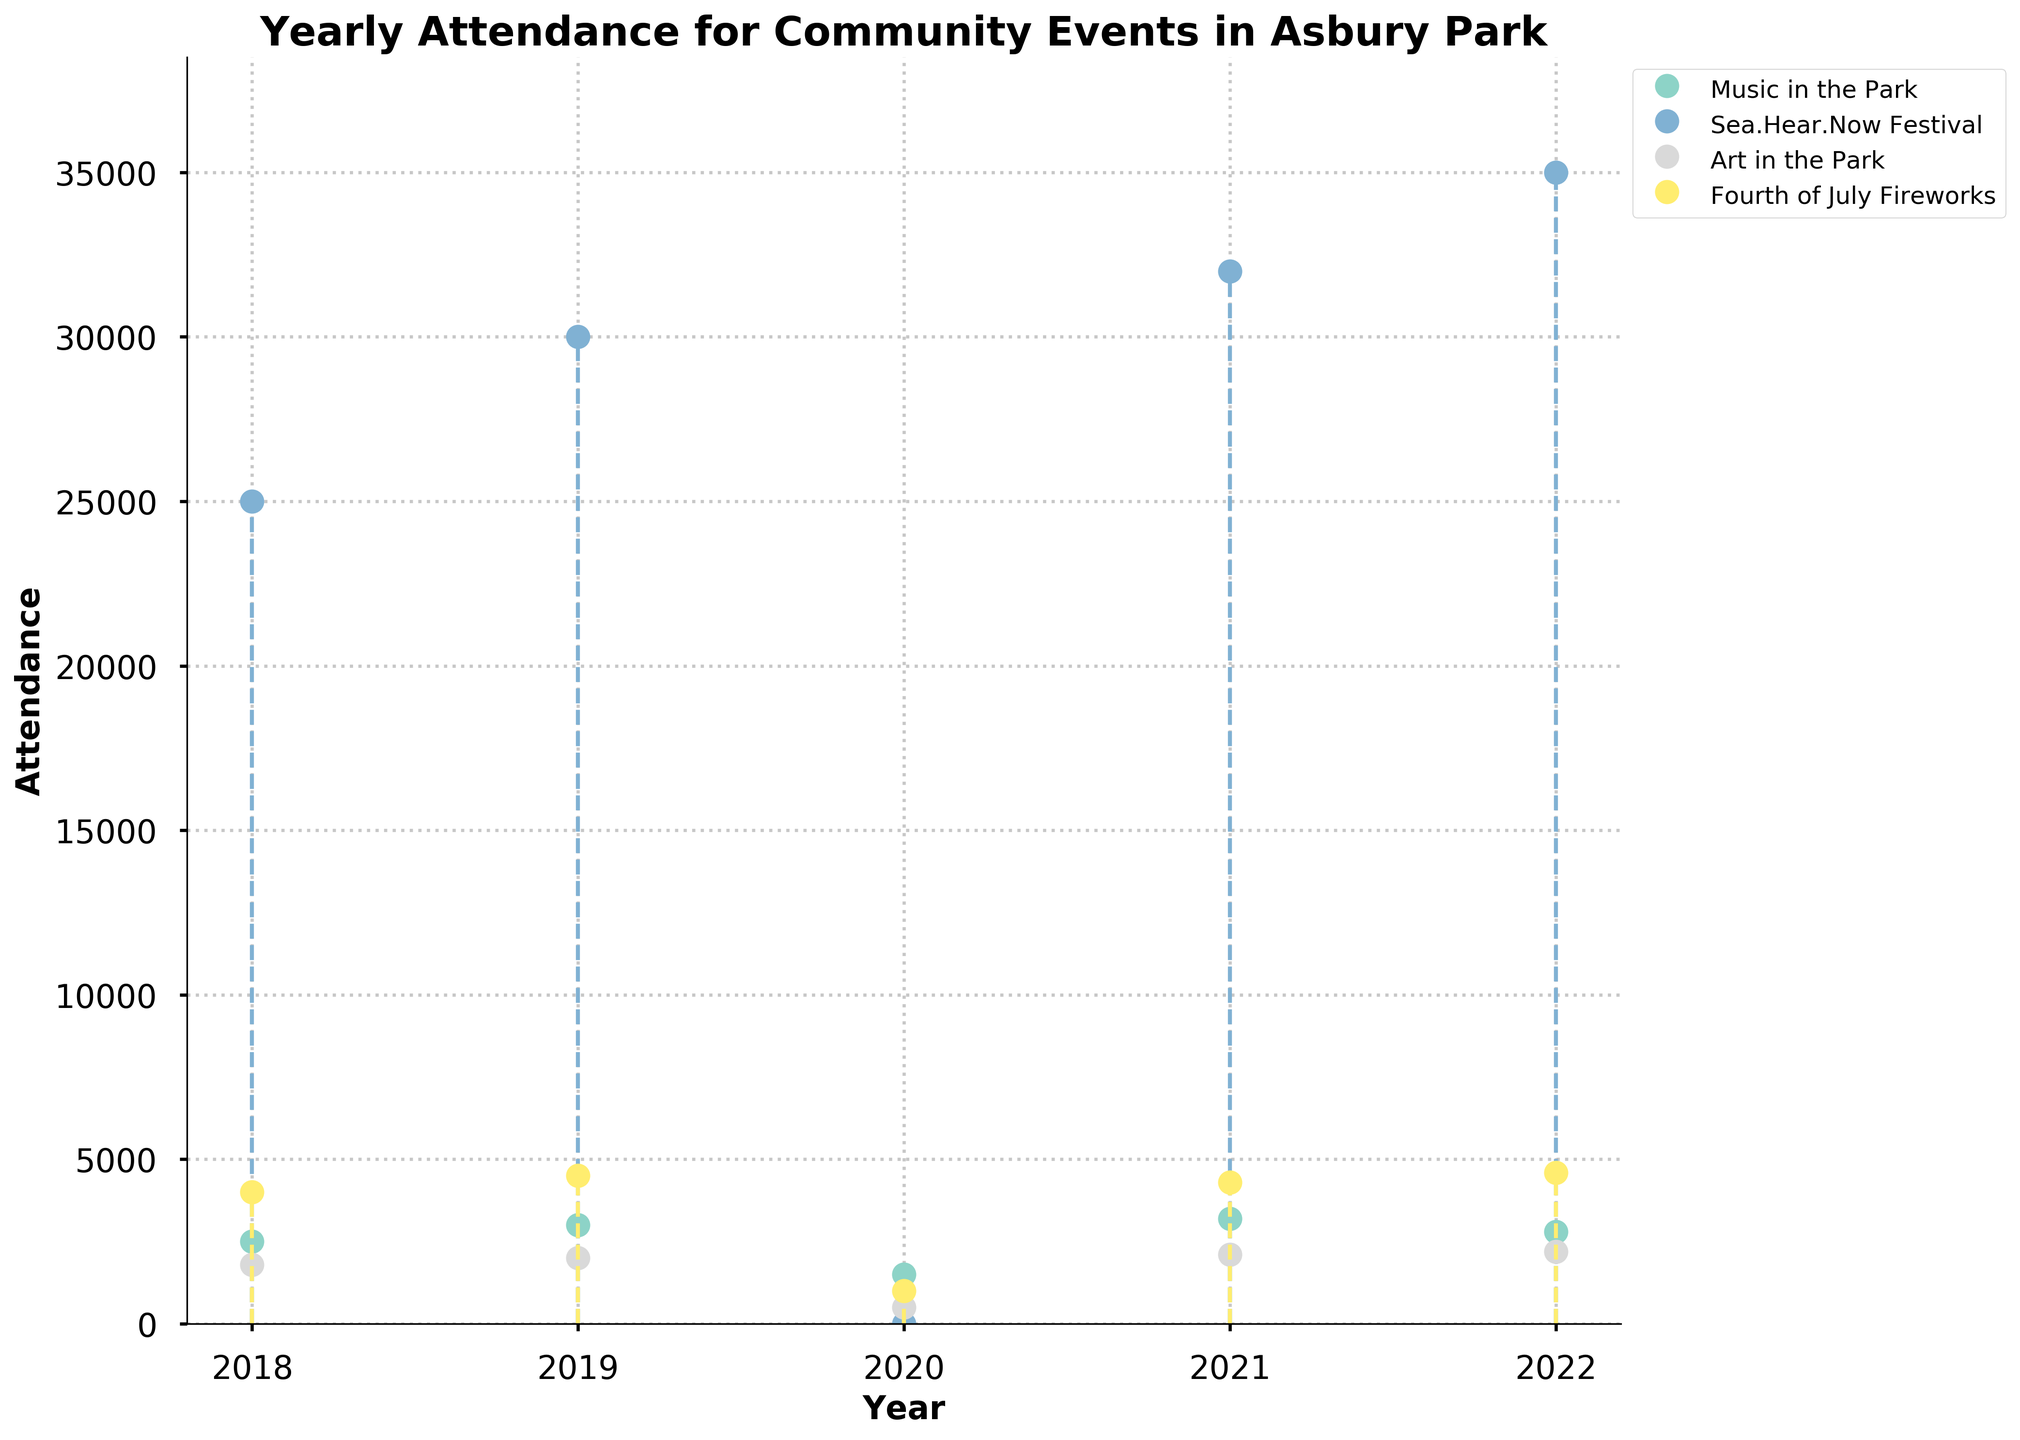What is the title of the figure? The title is written at the top of the figure in bold and large font.
Answer: Yearly Attendance for Community Events in Asbury Park How many unique events are shown in the figure? There are distinct lines or color-coding in the figure for each unique event.
Answer: Four Which event had the highest attendance in 2022? Look at the attendance values for 2022 on the x-axis and compare the heights of the markers for each event.
Answer: Sea.Hear.Now Festival What is the general trend in attendance for "Music in the Park" over the years? Observe the stem plot for "Music in the Park" and note whether the attendance values generally increase, decrease, or vary.
Answer: Varying with a drop in 2020 and a peak in 2021 How did the attendance for the "Fourth of July Fireworks" change from 2020 to 2021? Compare the attendance markers for "Fourth of July Fireworks" in 2020 and 2021.
Answer: Increased by 3300 What was the attendance for "Sea.Hear.Now Festival" in 2020, and why is it significant? Observe the attendance marker for "Sea.Hear.Now Festival" in 2020.
Answer: 0, likely due to the pandemic Which events showed a decrease in attendance from 2021 to 2022? Compare the 2021 and 2022 attendance markers for each event and identify those with a lower value in 2022.
Answer: Music in the Park By how much did the attendance for "Art in the Park" change from 2018 to 2022? Subtract the attendance value in 2018 from the value in 2022 for "Art in the Park."
Answer: Increased by 400 What is the average yearly attendance for "Music in the Park" from 2018 to 2022? Sum the attendance values for "Music in the Park" from 2018 to 2022 and divide by 5.
Answer: 2600 Which event had the most consistent attendance from 2018 to 2022? Look for the event with the least fluctuation in the height of markers across all years.
Answer: Art in the Park 